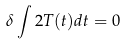<formula> <loc_0><loc_0><loc_500><loc_500>\delta \int 2 T ( t ) d t = 0</formula> 